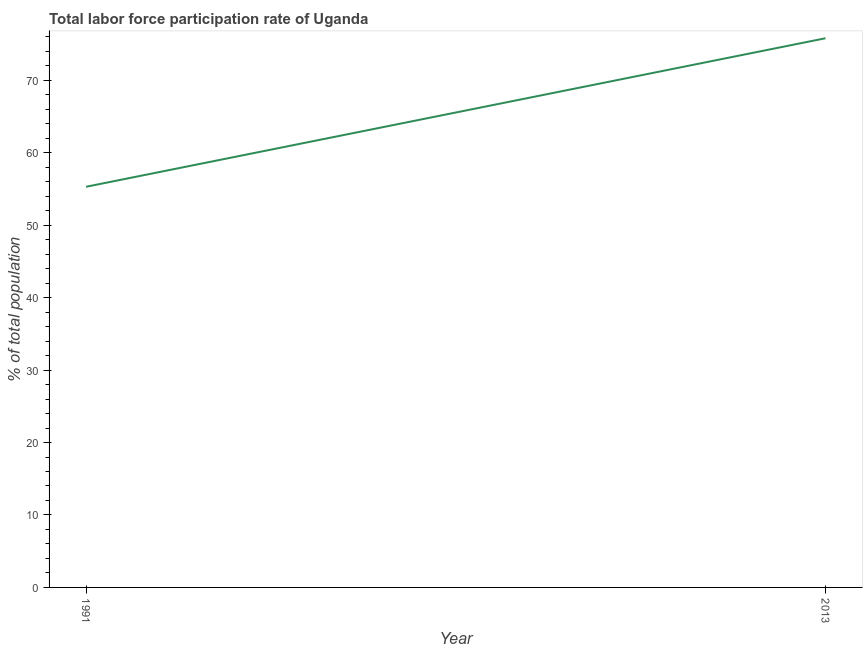What is the total labor force participation rate in 1991?
Make the answer very short. 55.3. Across all years, what is the maximum total labor force participation rate?
Your answer should be compact. 75.8. Across all years, what is the minimum total labor force participation rate?
Your response must be concise. 55.3. In which year was the total labor force participation rate maximum?
Provide a short and direct response. 2013. In which year was the total labor force participation rate minimum?
Keep it short and to the point. 1991. What is the sum of the total labor force participation rate?
Give a very brief answer. 131.1. What is the difference between the total labor force participation rate in 1991 and 2013?
Your answer should be compact. -20.5. What is the average total labor force participation rate per year?
Ensure brevity in your answer.  65.55. What is the median total labor force participation rate?
Make the answer very short. 65.55. In how many years, is the total labor force participation rate greater than 14 %?
Provide a succinct answer. 2. What is the ratio of the total labor force participation rate in 1991 to that in 2013?
Provide a succinct answer. 0.73. How many lines are there?
Give a very brief answer. 1. What is the title of the graph?
Provide a succinct answer. Total labor force participation rate of Uganda. What is the label or title of the Y-axis?
Provide a succinct answer. % of total population. What is the % of total population in 1991?
Your response must be concise. 55.3. What is the % of total population of 2013?
Your answer should be very brief. 75.8. What is the difference between the % of total population in 1991 and 2013?
Keep it short and to the point. -20.5. What is the ratio of the % of total population in 1991 to that in 2013?
Your response must be concise. 0.73. 